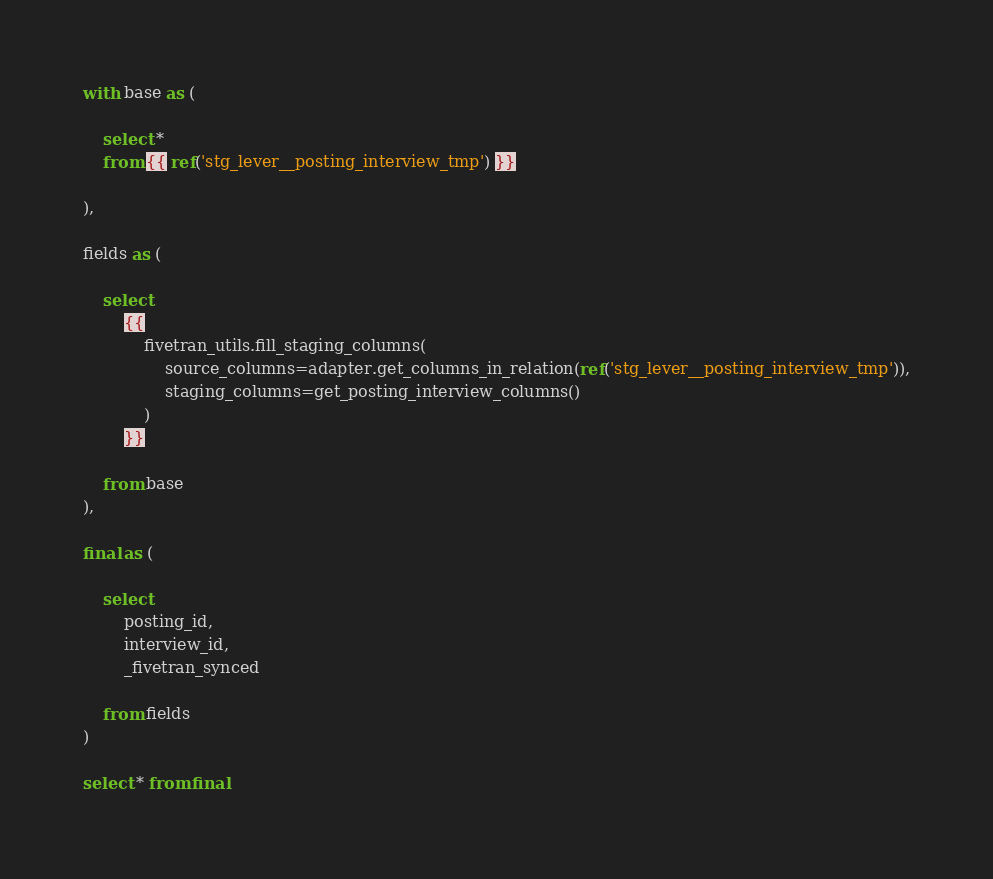<code> <loc_0><loc_0><loc_500><loc_500><_SQL_>
with base as (

    select * 
    from {{ ref('stg_lever__posting_interview_tmp') }}

),

fields as (

    select
        {{
            fivetran_utils.fill_staging_columns(
                source_columns=adapter.get_columns_in_relation(ref('stg_lever__posting_interview_tmp')),
                staging_columns=get_posting_interview_columns()
            )
        }}
        
    from base
),

final as (
    
    select 
        posting_id,
        interview_id,
        _fivetran_synced
        
    from fields
)

select * from final
</code> 